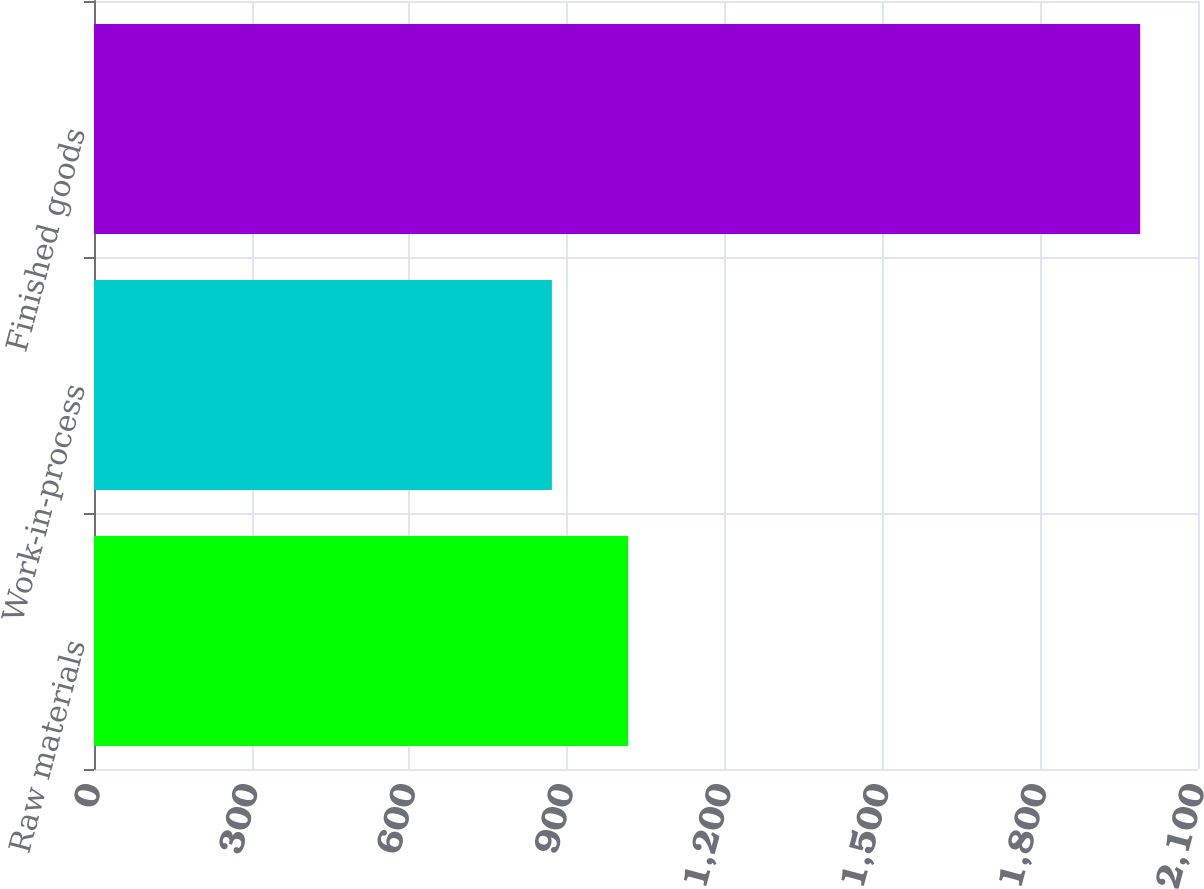Convert chart to OTSL. <chart><loc_0><loc_0><loc_500><loc_500><bar_chart><fcel>Raw materials<fcel>Work-in-process<fcel>Finished goods<nl><fcel>1016<fcel>871<fcel>1990<nl></chart> 